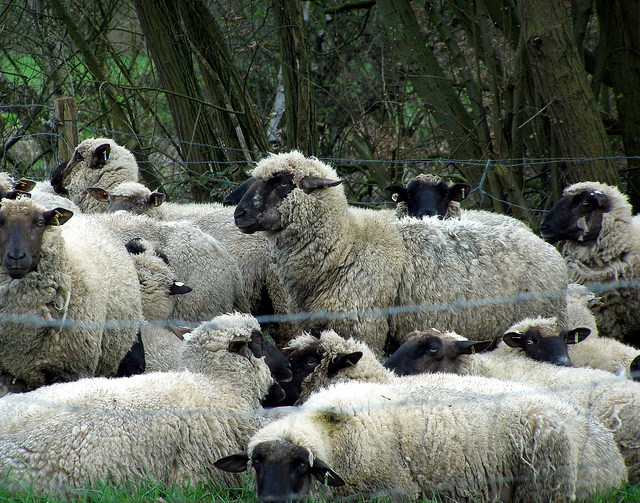What kind of environment are the sheep living in? The sheep are situated in a rural, pastoral environment characterized by dense trees and vegetation. The presence of a fence suggests a controlled grazing area, typical for farm settings where sheep have ample space to roam and access to natural resources. Are the sheep likely to encounter any predators here? In such a pastoral setting, potential predators could include foxes or even stray dogs. However, the presence of the fence and possibly a nearby shepherd helps mitigate these risks, offering protection to the flock. If these sheep were characters in a storybook, what would the main plot be? In a storybook, these sheep might embark on an adventure after one curious sheep spots a strange, glowing object beyond the fence at night. Driven by curiosity, the flock decides to investigate, leading them through enchanted forests, across rivers, and into mysterious caves. Along the way, they learn about courage, teamwork, and the power of friendship as they seek to uncover the secret of the mysterious object. Could you describe how this image would look like if it was winter? In winter, the scene would change drastically. The lush greenery would be replaced with a layer of snow covering the ground and the trees. The sheep's coats might appear even fluffier, as they'd be puffy with their warm winter wool. Their breath would create small clouds in the cold air, and the overall setting would look serene and quiet, with a crisp, white backdrop. 